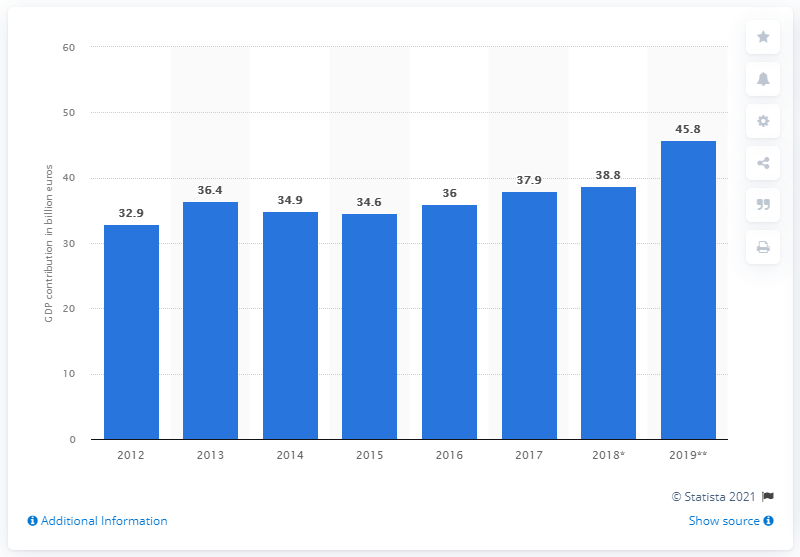Indicate a few pertinent items in this graphic. In 2012, the contribution of travel and tourism to the country's gross domestic product was 32.9%. In 2019, the contribution of travel and tourism to the Gross Domestic Product (GDP) of the Netherlands was 45.8%. 